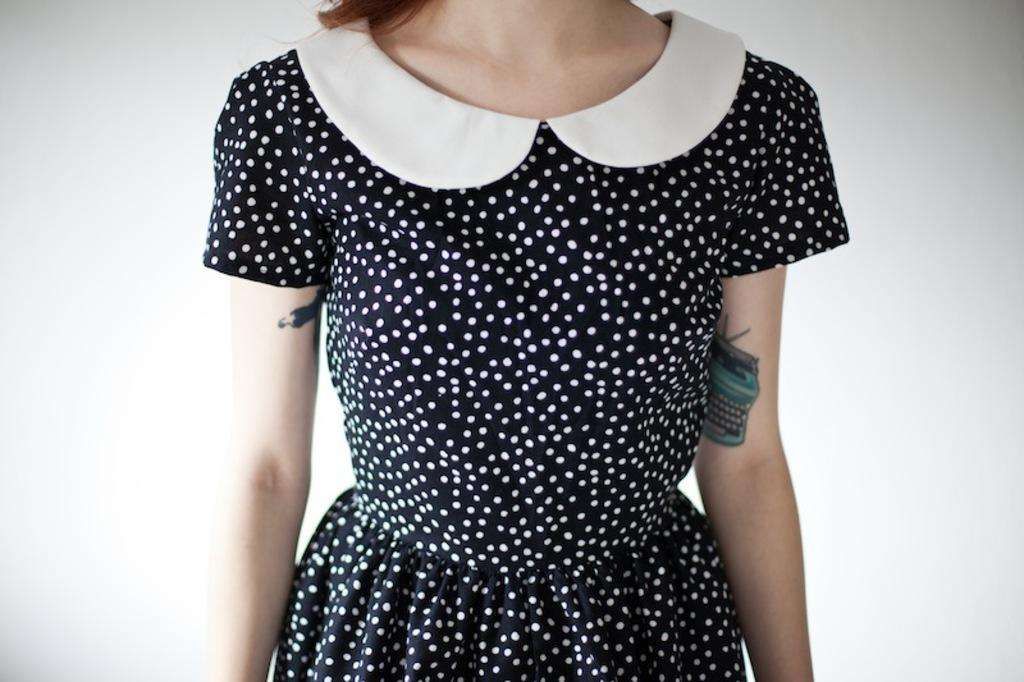Who is the main subject in the image? There is a lady in the image. What is the lady wearing? The lady is wearing a black dress with white spots. What is the color of the background in the image? The background in the image is white. What type of pin can be seen on the lady's dress in the image? There is no pin visible on the lady's dress in the image. 